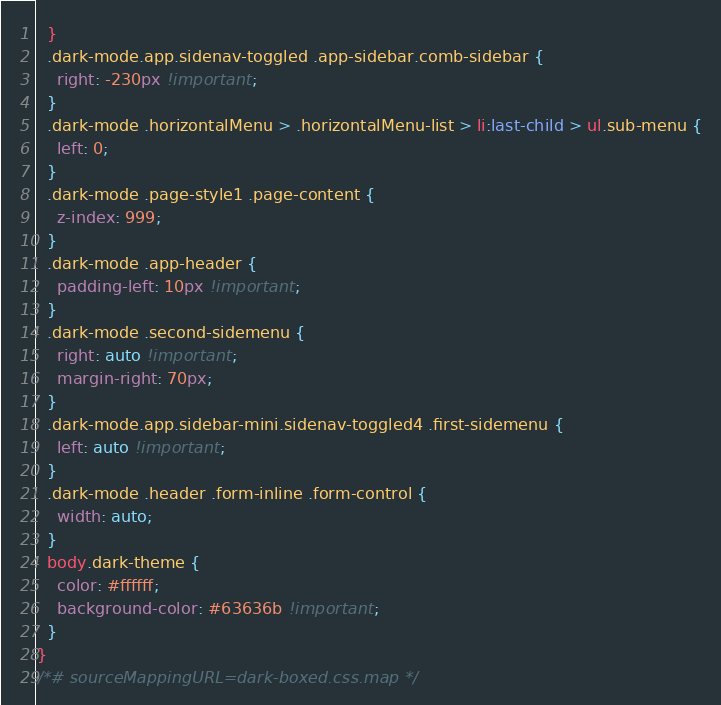<code> <loc_0><loc_0><loc_500><loc_500><_CSS_>  }
  .dark-mode.app.sidenav-toggled .app-sidebar.comb-sidebar {
    right: -230px !important;
  }
  .dark-mode .horizontalMenu > .horizontalMenu-list > li:last-child > ul.sub-menu {
    left: 0;
  }
  .dark-mode .page-style1 .page-content {
    z-index: 999;
  }
  .dark-mode .app-header {
    padding-left: 10px !important;
  }
  .dark-mode .second-sidemenu {
    right: auto !important;
    margin-right: 70px;
  }
  .dark-mode.app.sidebar-mini.sidenav-toggled4 .first-sidemenu {
    left: auto !important;
  }
  .dark-mode .header .form-inline .form-control {
    width: auto;
  }
  body.dark-theme {
    color: #ffffff;
    background-color: #63636b !important;
  }
}
/*# sourceMappingURL=dark-boxed.css.map */</code> 